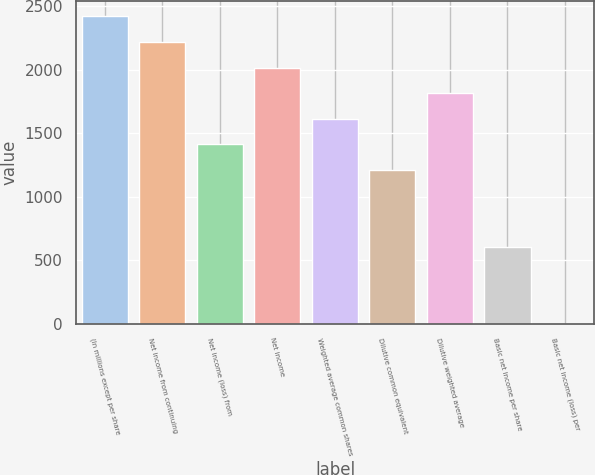Convert chart. <chart><loc_0><loc_0><loc_500><loc_500><bar_chart><fcel>(In millions except per share<fcel>Net income from continuing<fcel>Net income (loss) from<fcel>Net income<fcel>Weighted average common shares<fcel>Dilutive common equivalent<fcel>Dilutive weighted average<fcel>Basic net income per share<fcel>Basic net income (loss) per<nl><fcel>2417.93<fcel>2216.45<fcel>1410.53<fcel>2014.97<fcel>1612.01<fcel>1209.05<fcel>1813.49<fcel>604.61<fcel>0.17<nl></chart> 